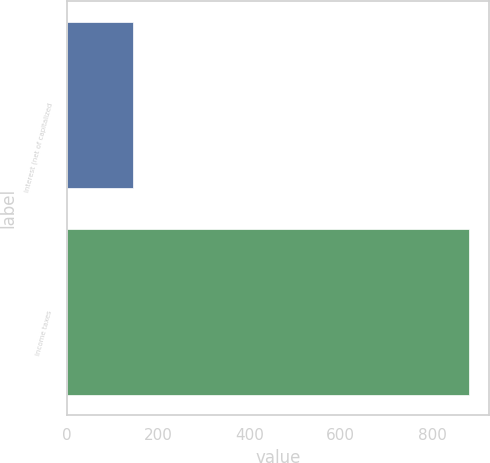Convert chart. <chart><loc_0><loc_0><loc_500><loc_500><bar_chart><fcel>Interest (net of capitalized<fcel>Income taxes<nl><fcel>145<fcel>880<nl></chart> 